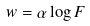Convert formula to latex. <formula><loc_0><loc_0><loc_500><loc_500>w = \alpha \log F</formula> 